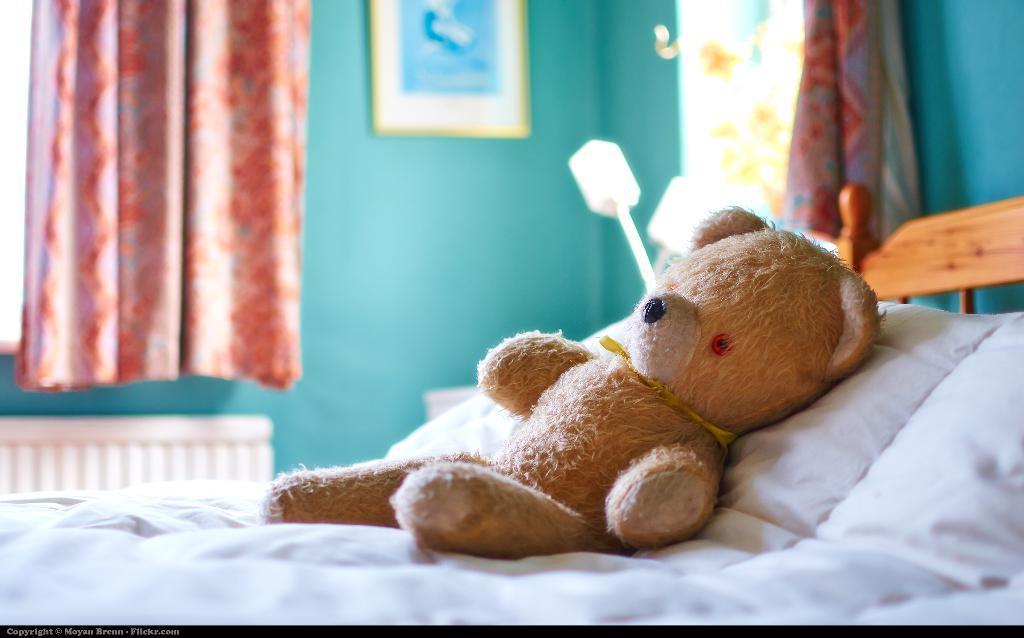Describe this image in one or two sentences. In a room there i s bed in which teddy bear slept on that. On the other side there is a window curtain hanging and we can also see a lamp standing on the other end. 